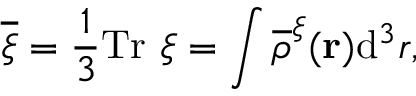<formula> <loc_0><loc_0><loc_500><loc_500>\overline { \xi } = \frac { 1 } { 3 } T r \xi = \int \overline { \rho } ^ { \xi } ( { r } ) d ^ { 3 } r ,</formula> 